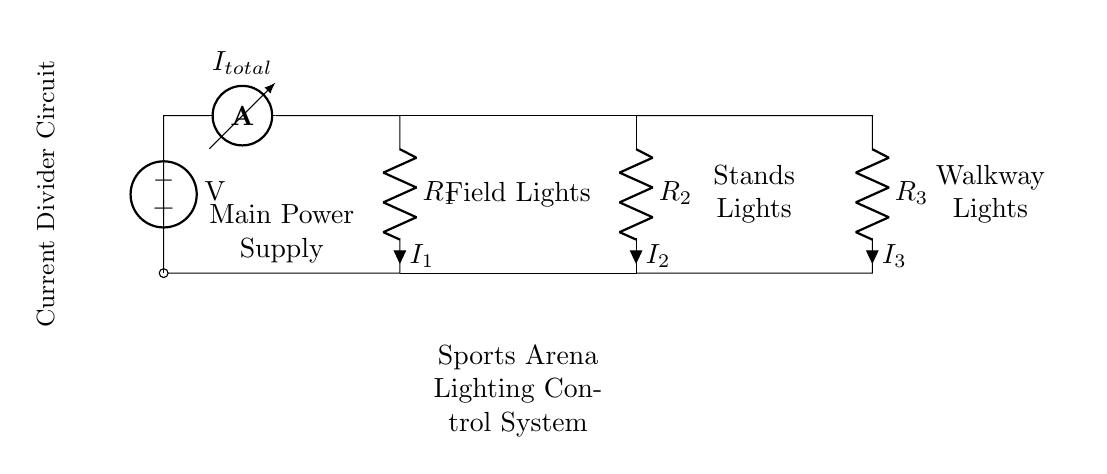What is the total current entering the circuit? The total current entering the circuit is denoted as I_total, which is indicated by the ammeter symbol at the top of the circuit diagram.
Answer: I_total What are the resistance values in this circuit? The circuit shows three resistors labeled R_1, R_2, and R_3, but their specific resistance values are not provided in the diagram itself.
Answer: Not specified Which components represent the field lights in this circuit? The field lights are represented by the resistor R_1, which is clearly labeled as "Field Lights" in the circuit diagram.
Answer: R_1 If R_2 is increased, what happens to I_2? According to the principles of current division, if R_2 increases, the current I_2 will decrease, because a larger resistance will draw less current in comparison to the other branches of the circuit.
Answer: Decreases How many branches does the current divide into? The circuit divides the current into three branches, one for each of the resistors R_1, R_2, and R_3.
Answer: Three What is the function of the ammeter in this circuit? The ammeter is used to measure the total current flowing into the circuit, providing an indication of the overall current that is divided across the various resistors.
Answer: Measure total current What effect does decreasing R_3 have on I_3 in this circuit? Decreasing R_3 will lead to an increase in I_3, since a lower resistance allows greater current to flow according to the current division rule.
Answer: Increases 